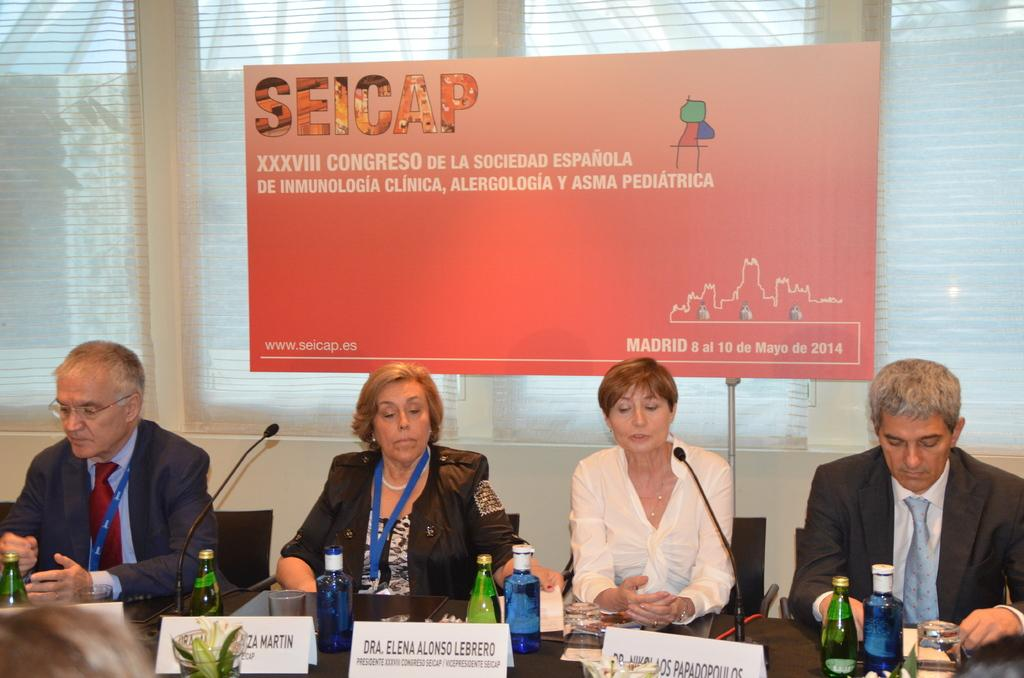<image>
Present a compact description of the photo's key features. A panel of four people at a SEICAP meeting in Madrid. 